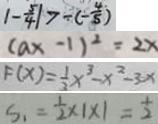Convert formula to latex. <formula><loc_0><loc_0><loc_500><loc_500>\vert - \frac { 5 } { 4 } \vert > - ( - \frac { 4 } { 5 } ) 
 ( a x - 1 ) ^ { 2 } = 2 x 
 F ( x ) = \frac { 1 } { 3 } x ^ { 3 } - x ^ { 2 } - 3 x 
 S _ { 1 } = \frac { 1 } { 2 } \times 1 \times 1 = \frac { 1 } { 2 }</formula> 